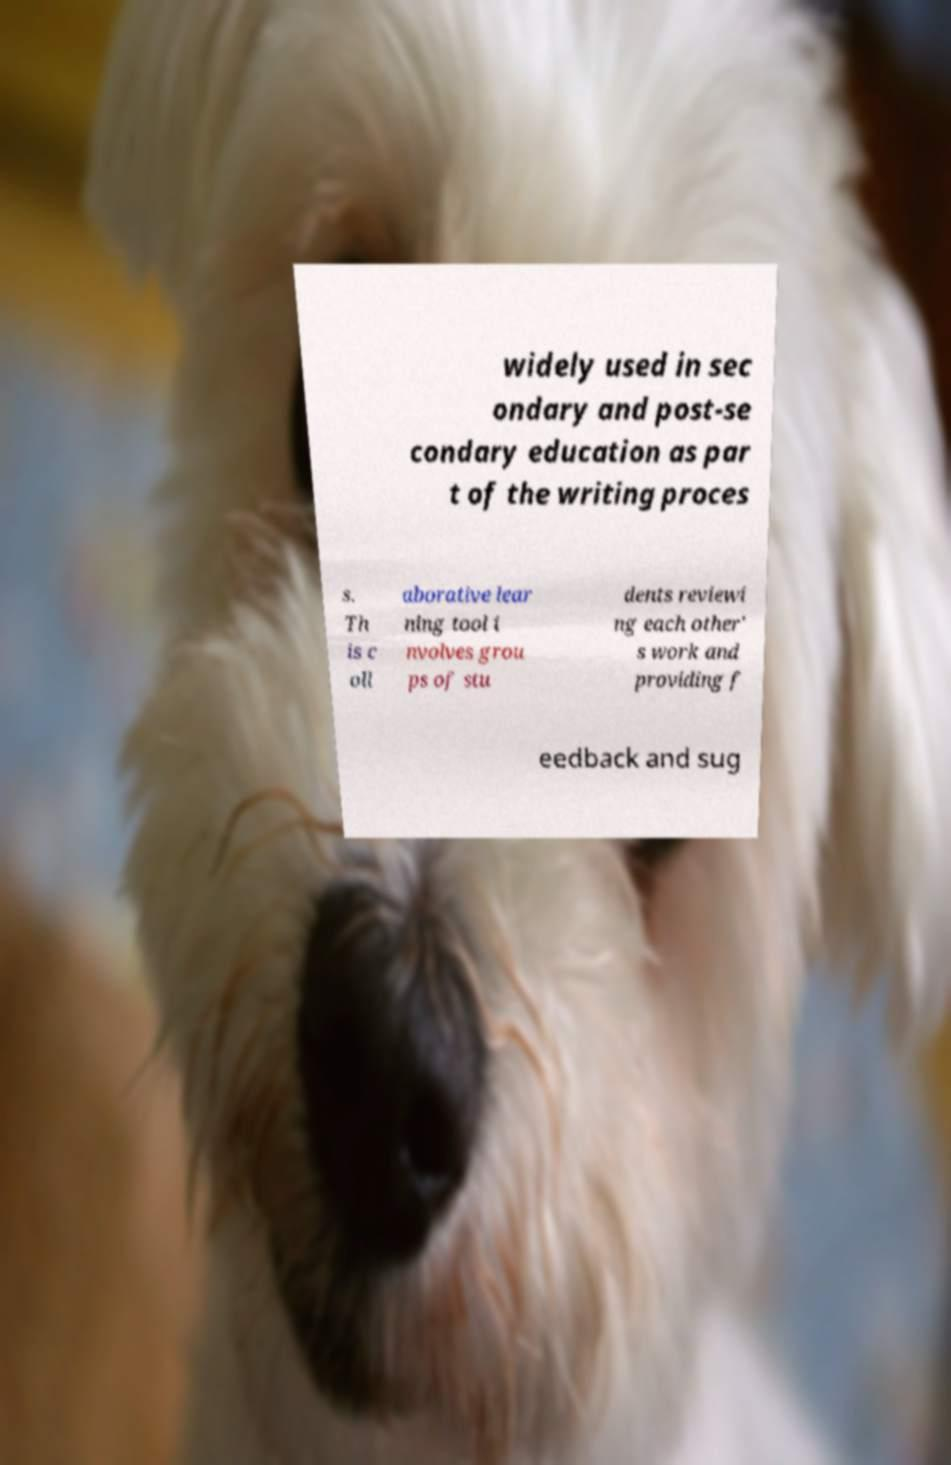There's text embedded in this image that I need extracted. Can you transcribe it verbatim? widely used in sec ondary and post-se condary education as par t of the writing proces s. Th is c oll aborative lear ning tool i nvolves grou ps of stu dents reviewi ng each other' s work and providing f eedback and sug 